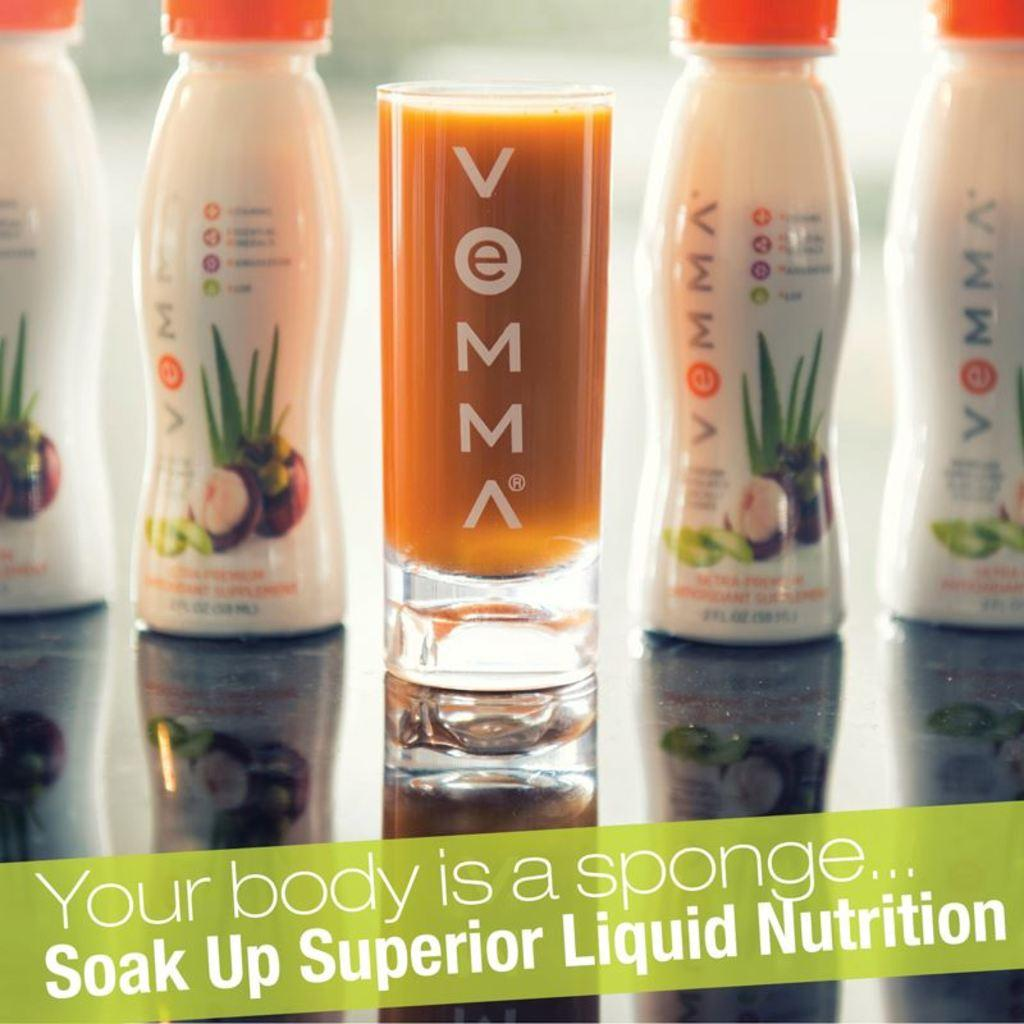<image>
Provide a brief description of the given image. A shot glass filled with Vemma nutritional drink. 